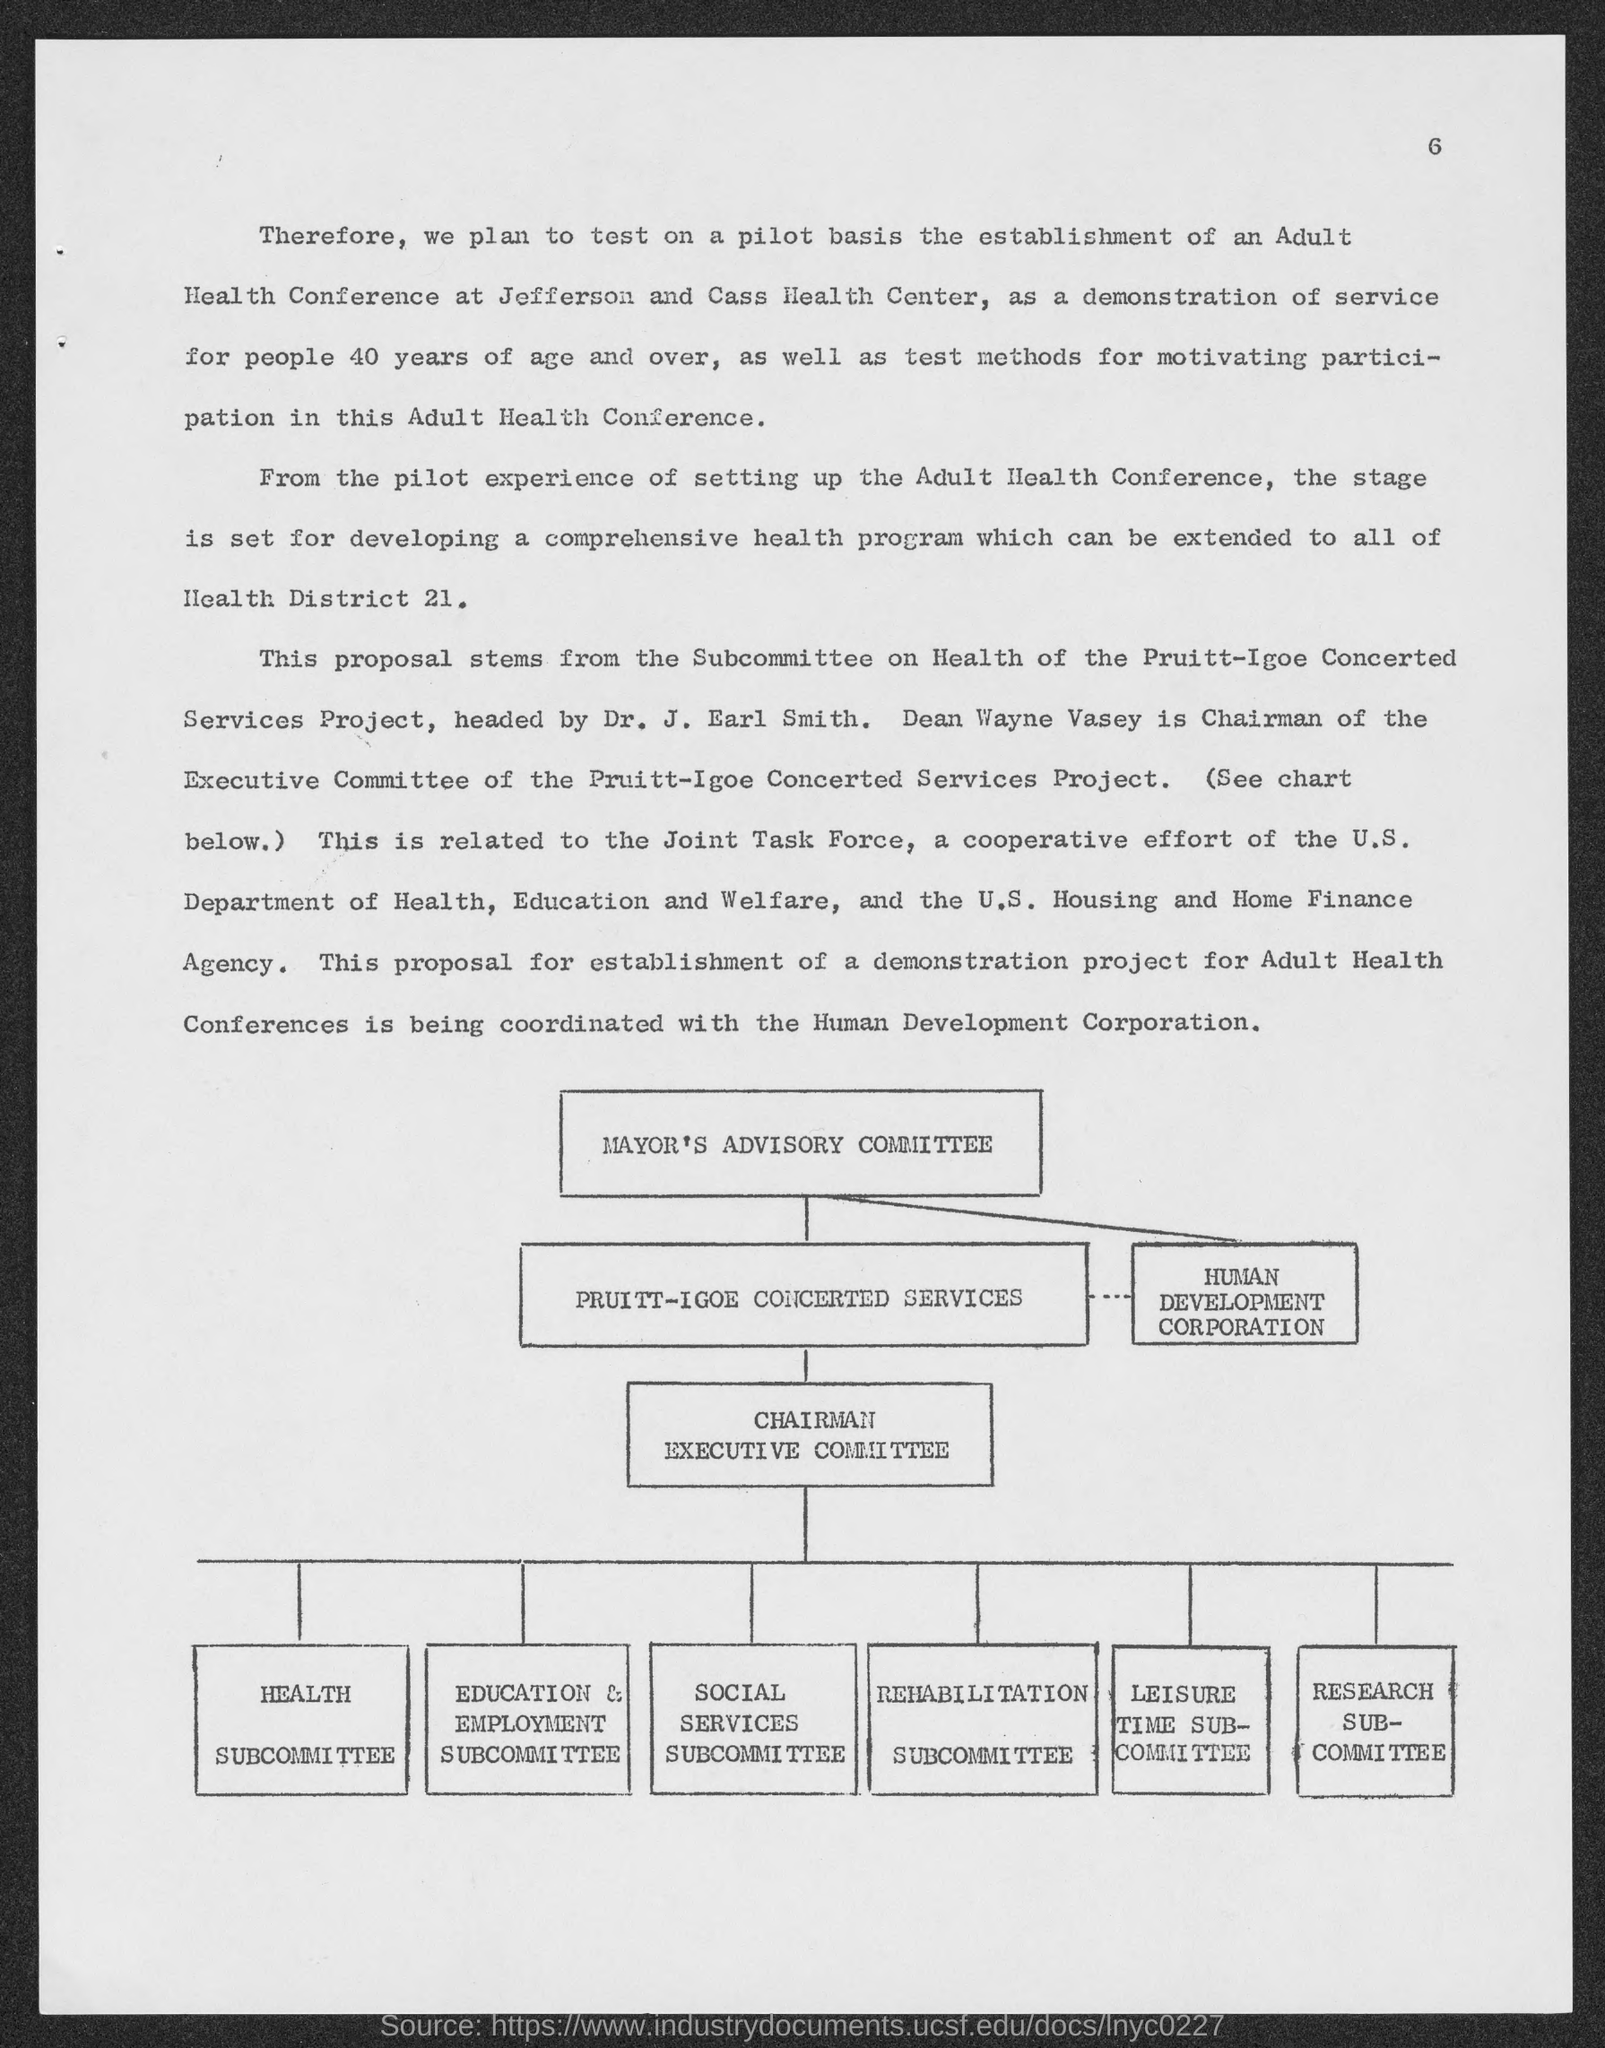What is the page no mentioned in the document?
Make the answer very short. 6. Who is the Chairman of the Executive Committee of the Pruitt-Igoe Concerted Services Project?
Your answer should be very brief. DEAN WAYNE VASEY. 